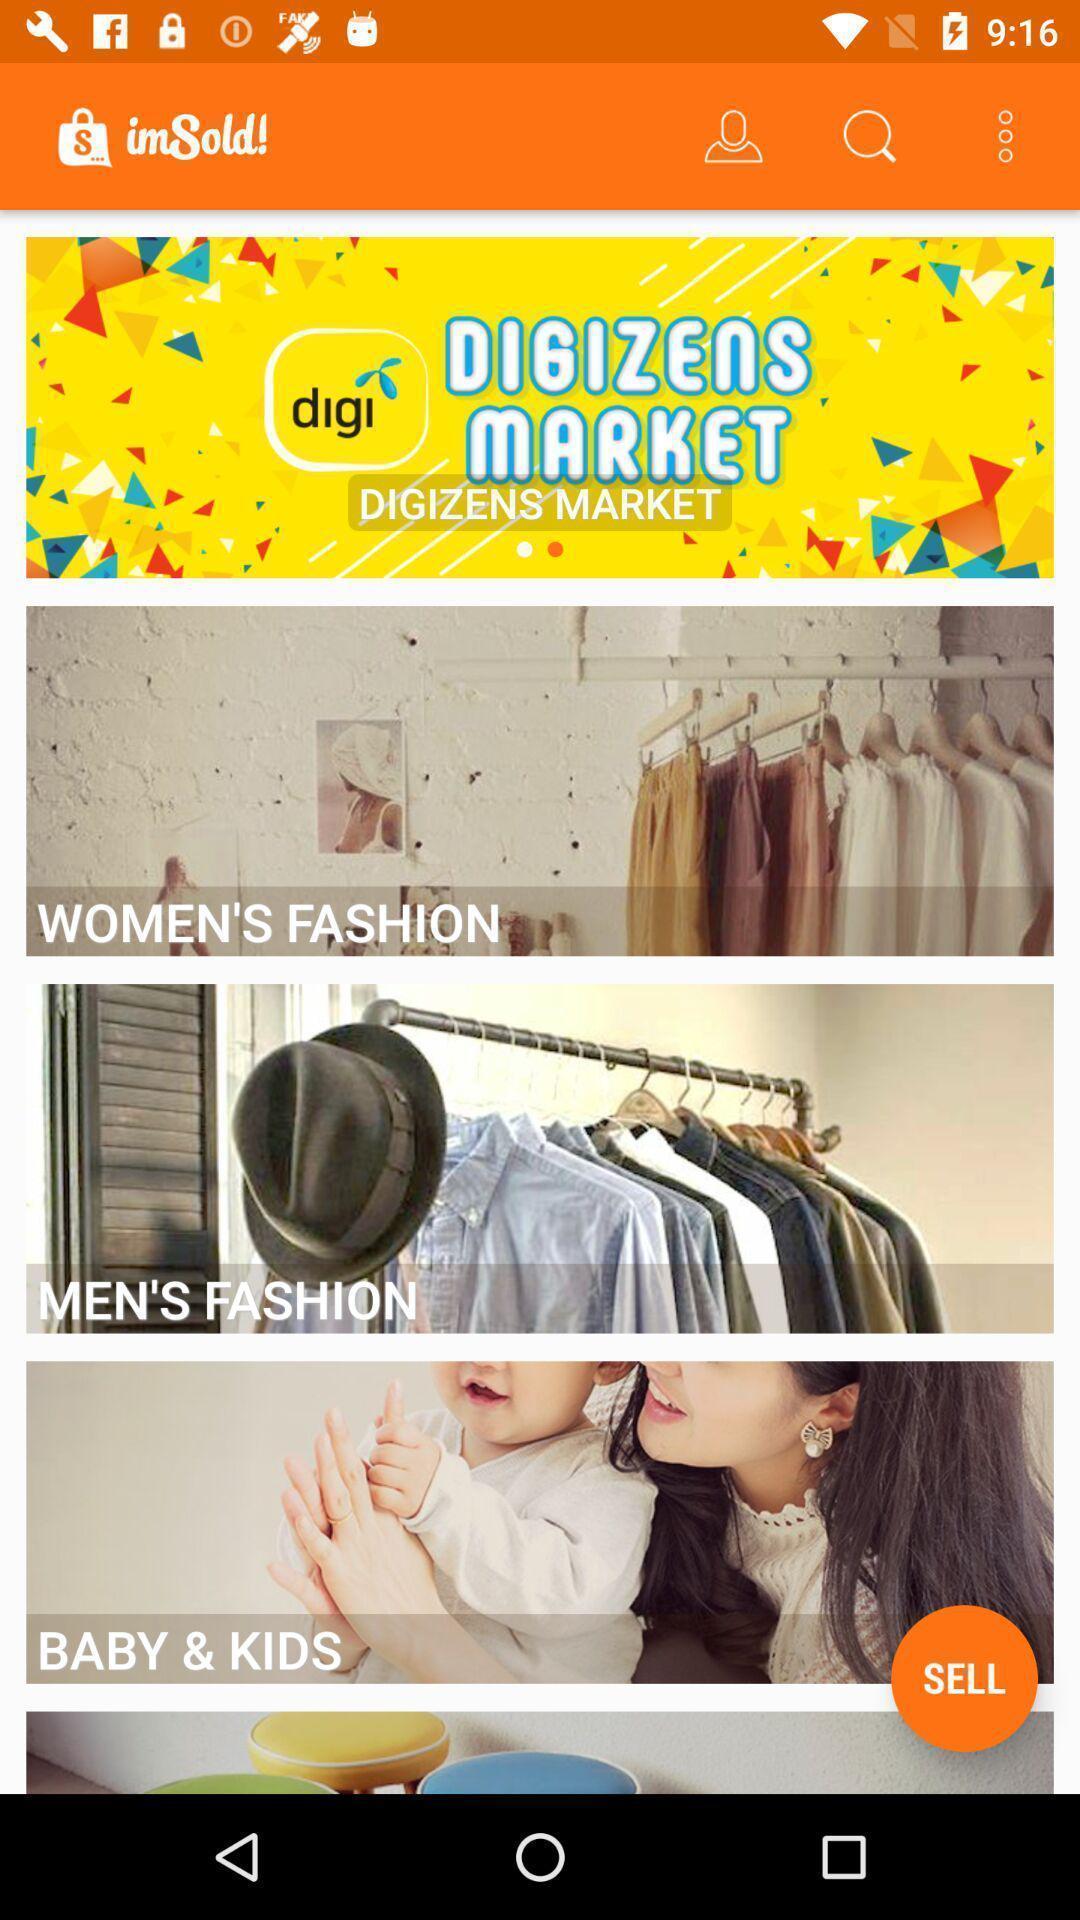What details can you identify in this image? Page showing products from shopping website. 